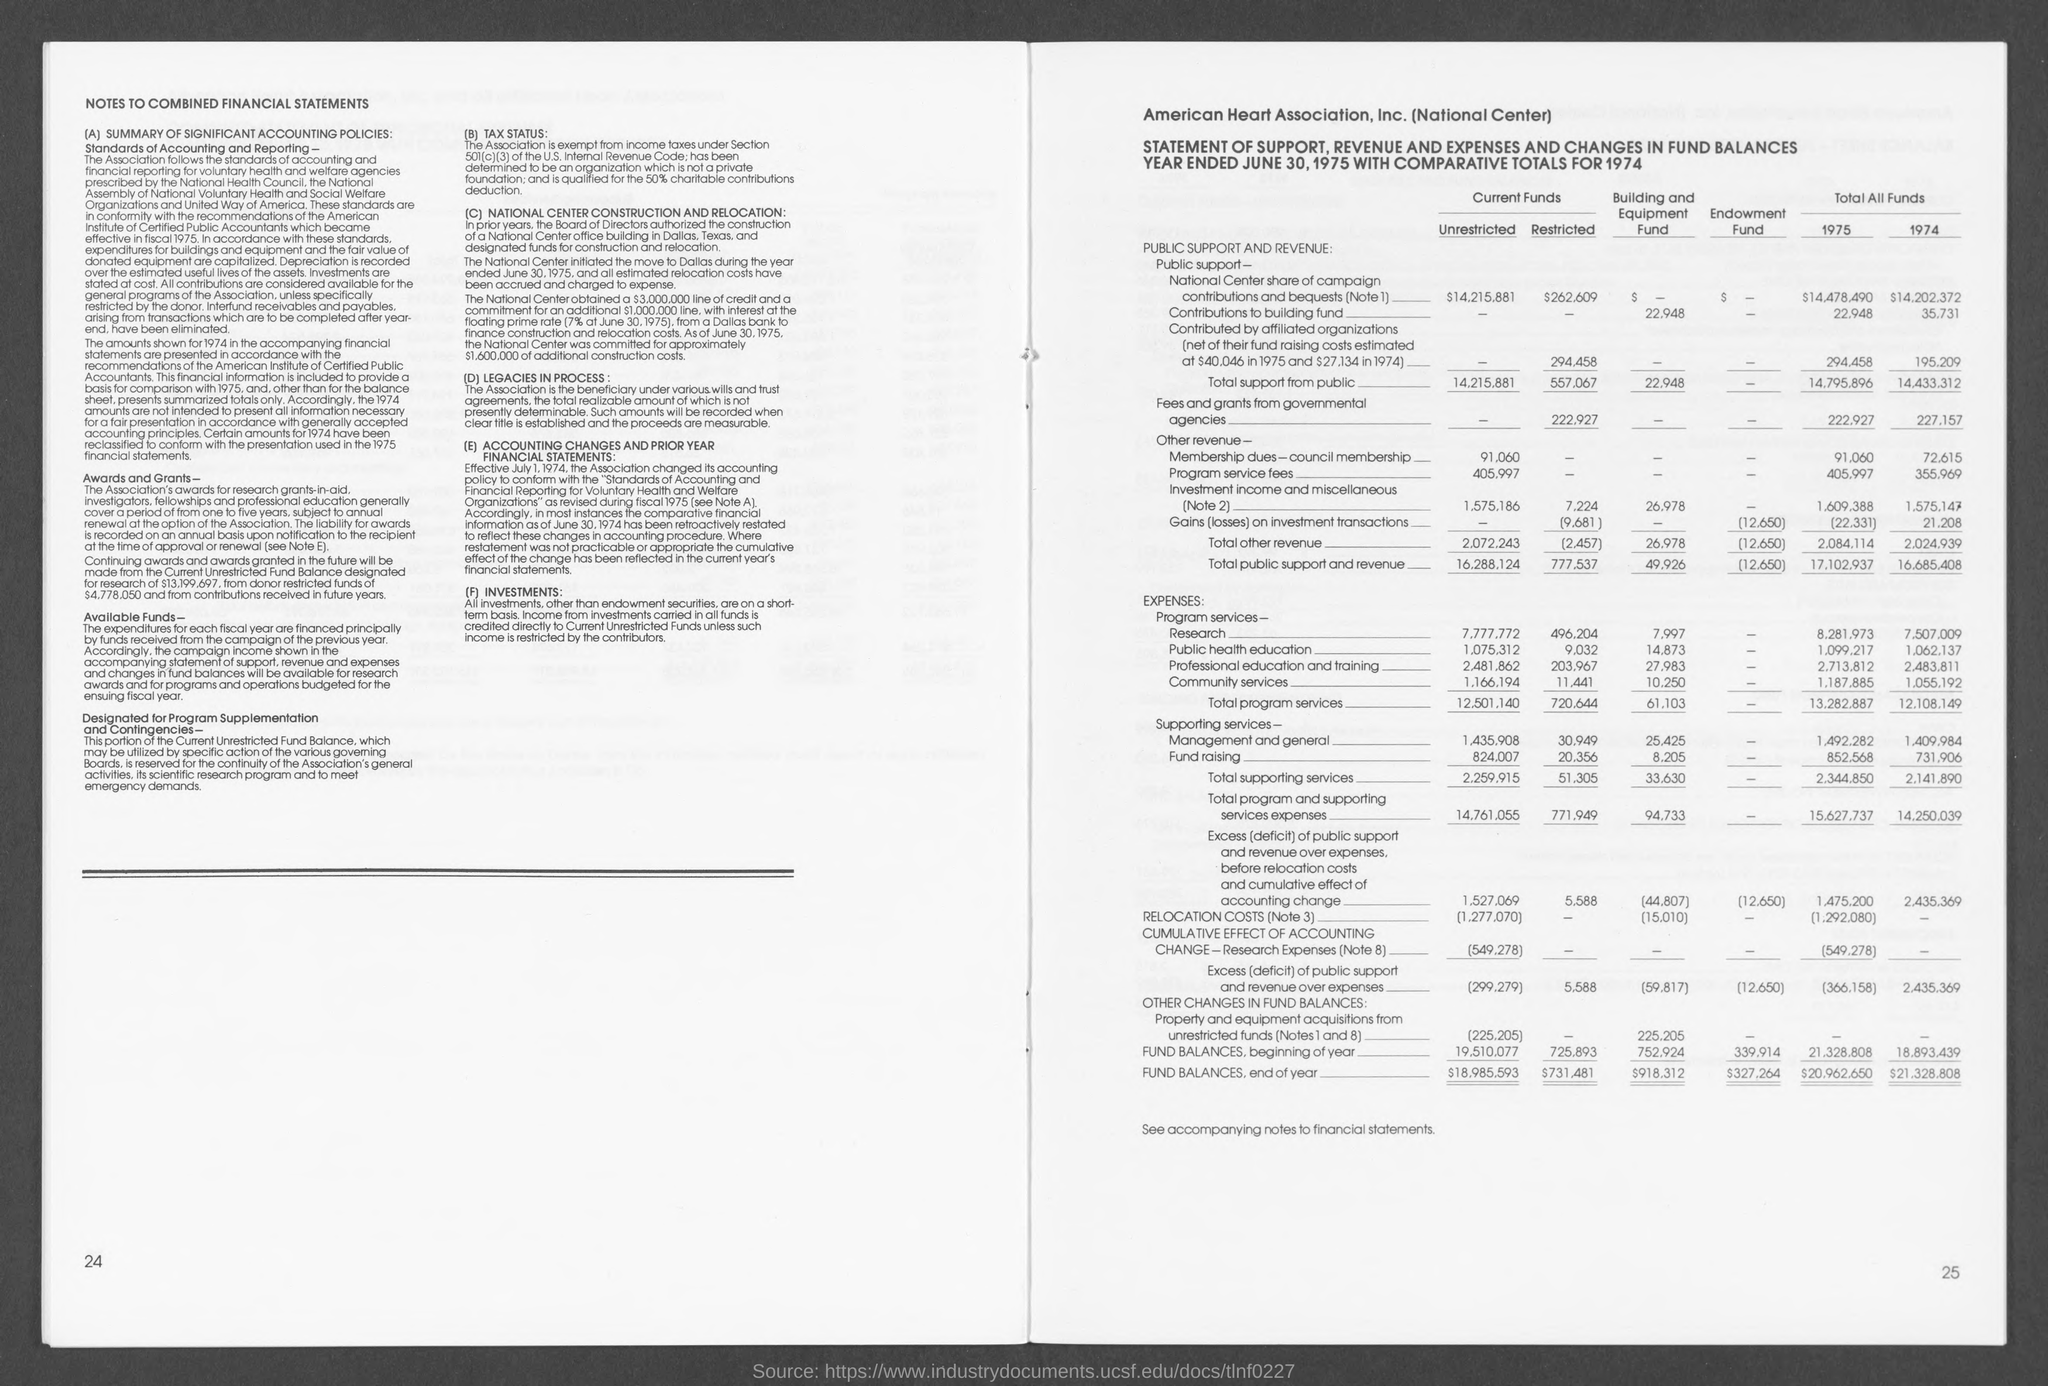What is the Fund Balances, end of year for Unrestricted current funds?
Your response must be concise. $18,985,593. What is the Fund Balances, end of year for restricted current funds?
Offer a terse response. $731,481. What is the Fund Balances, end of year for Building and equipment fund?
Offer a terse response. 918,312. What is the Fund Balances, end of year for endowment funds?
Ensure brevity in your answer.  $327,264. 